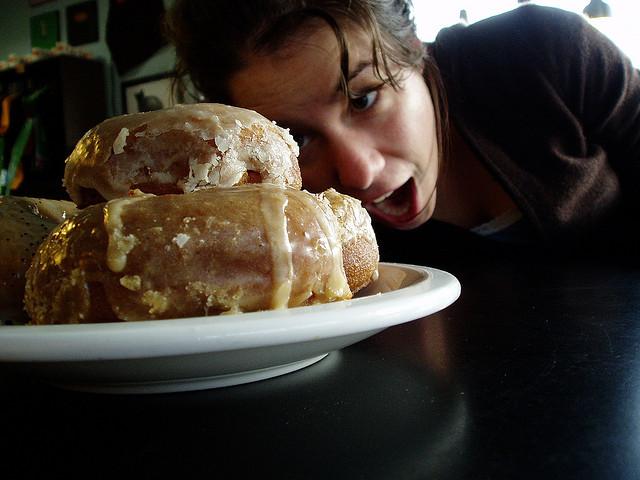Does she look eager to have one?
Short answer required. Yes. What is the plate on?
Quick response, please. Table. What is for dessert?
Short answer required. Donuts. What color hair does the girl have?
Short answer required. Brown. 